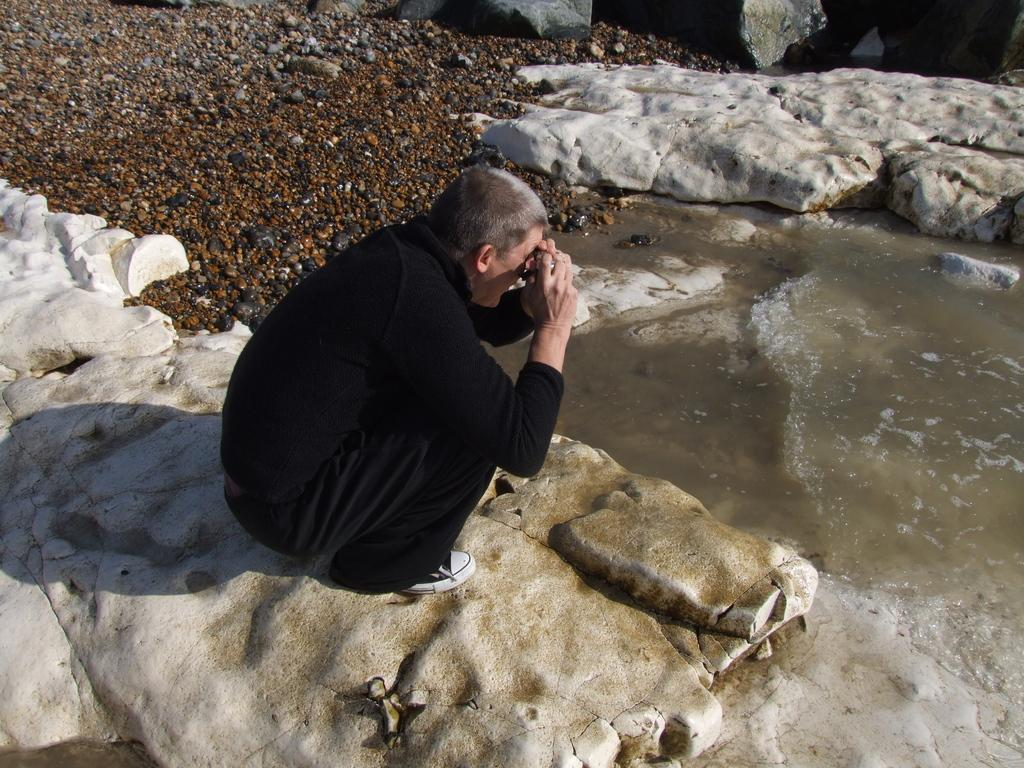Who or what is the main subject in the image? There is a person in the image. What is the person standing on? The person is on a stone surface. What is the person holding in the image? The person is holding an object. What can be seen on the right side of the image? There is water visible on the right side of the image. What type of natural elements are present at the top of the image? Rocks and stones are present at the top of the image. What type of jeans is the person wearing in the image? There is no information about the person's clothing in the image, so we cannot determine if they are wearing jeans or any other type of garment. What kind of club does the person belong to in the image? There is no indication of any clubs or organizations in the image, so we cannot determine if the person belongs to any club. 